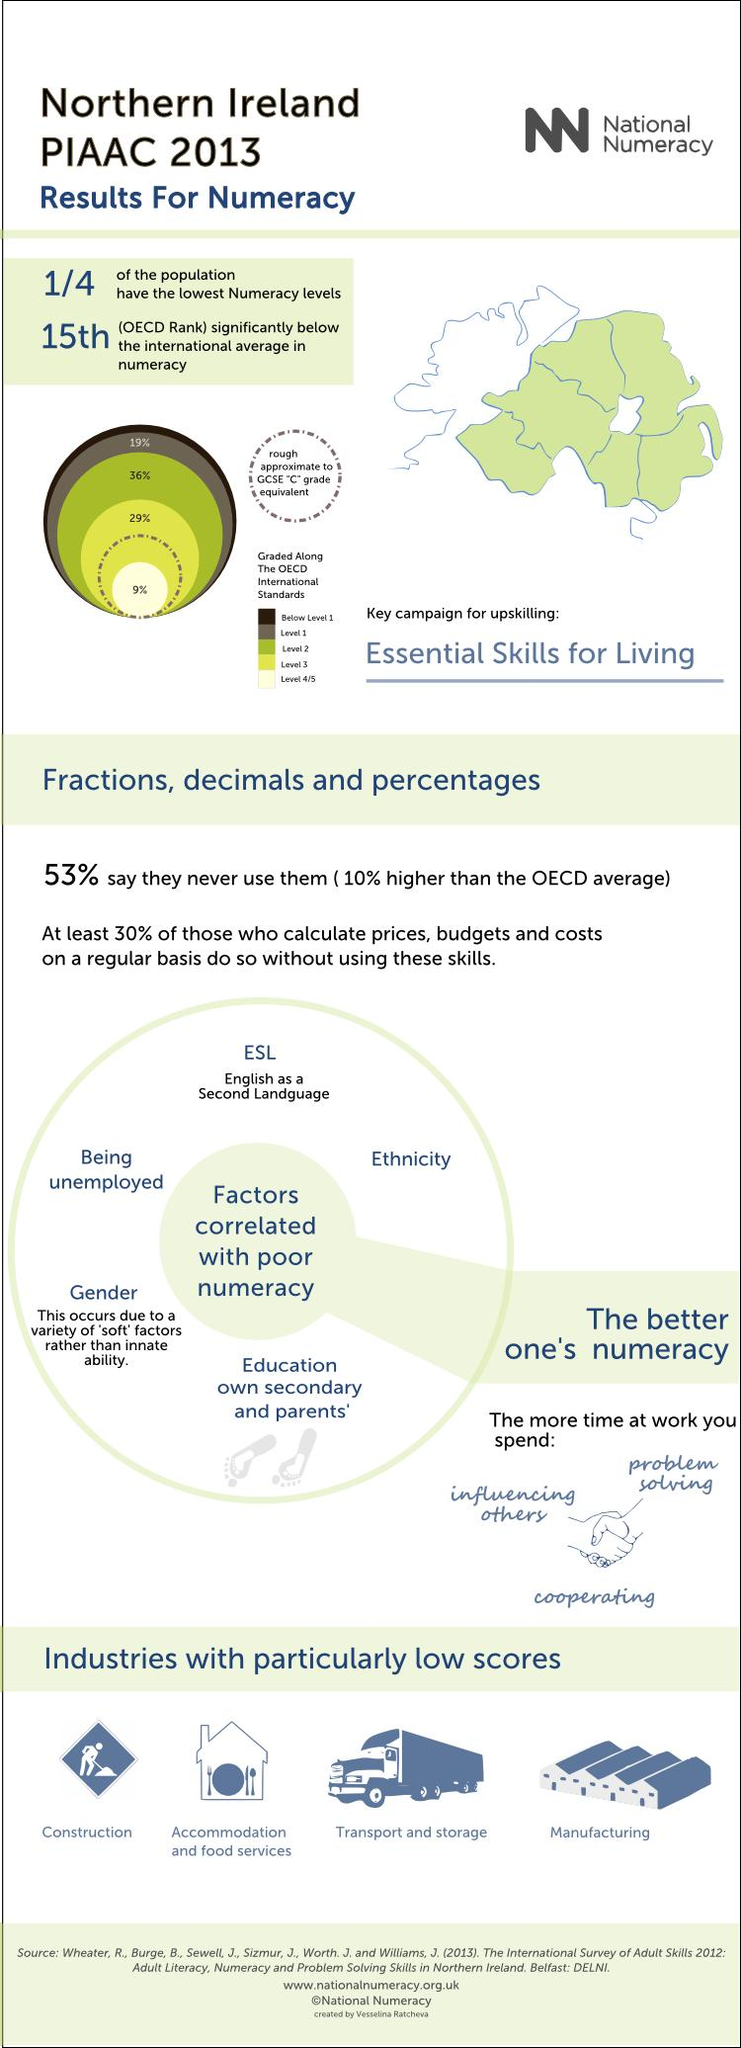Give some essential details in this illustration. Thirty-six percent is at level 2. Northern Ireland ranks 15th in the world. According to the data, approximately 25% of the population have the lowest numeracy levels. Out of the various industries we analyzed, those with particularly low scores numbered only 4. 